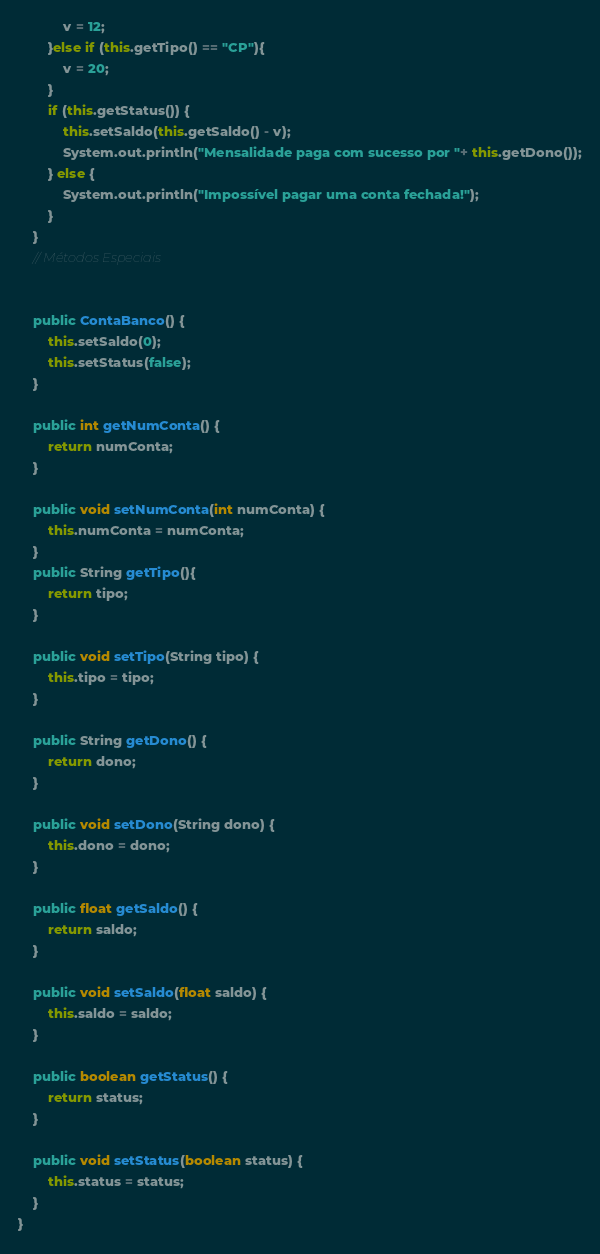Convert code to text. <code><loc_0><loc_0><loc_500><loc_500><_Java_>            v = 12;
        }else if (this.getTipo() == "CP"){
            v = 20;
        }
        if (this.getStatus()) {
            this.setSaldo(this.getSaldo() - v);
            System.out.println("Mensalidade paga com sucesso por "+ this.getDono());
        } else {
            System.out.println("Impossível pagar uma conta fechada!");
        }
    }
    // Métodos Especiais


    public ContaBanco() {
        this.setSaldo(0);
        this.setStatus(false);
    }

    public int getNumConta() {
        return numConta;
    }

    public void setNumConta(int numConta) {
        this.numConta = numConta;
    }
    public String getTipo(){
        return tipo;
    }

    public void setTipo(String tipo) {
        this.tipo = tipo;
    }

    public String getDono() {
        return dono;
    }

    public void setDono(String dono) {
        this.dono = dono;
    }

    public float getSaldo() {
        return saldo;
    }

    public void setSaldo(float saldo) {
        this.saldo = saldo;
    }

    public boolean getStatus() {
        return status;
    }

    public void setStatus(boolean status) {
        this.status = status;
    }
}
</code> 